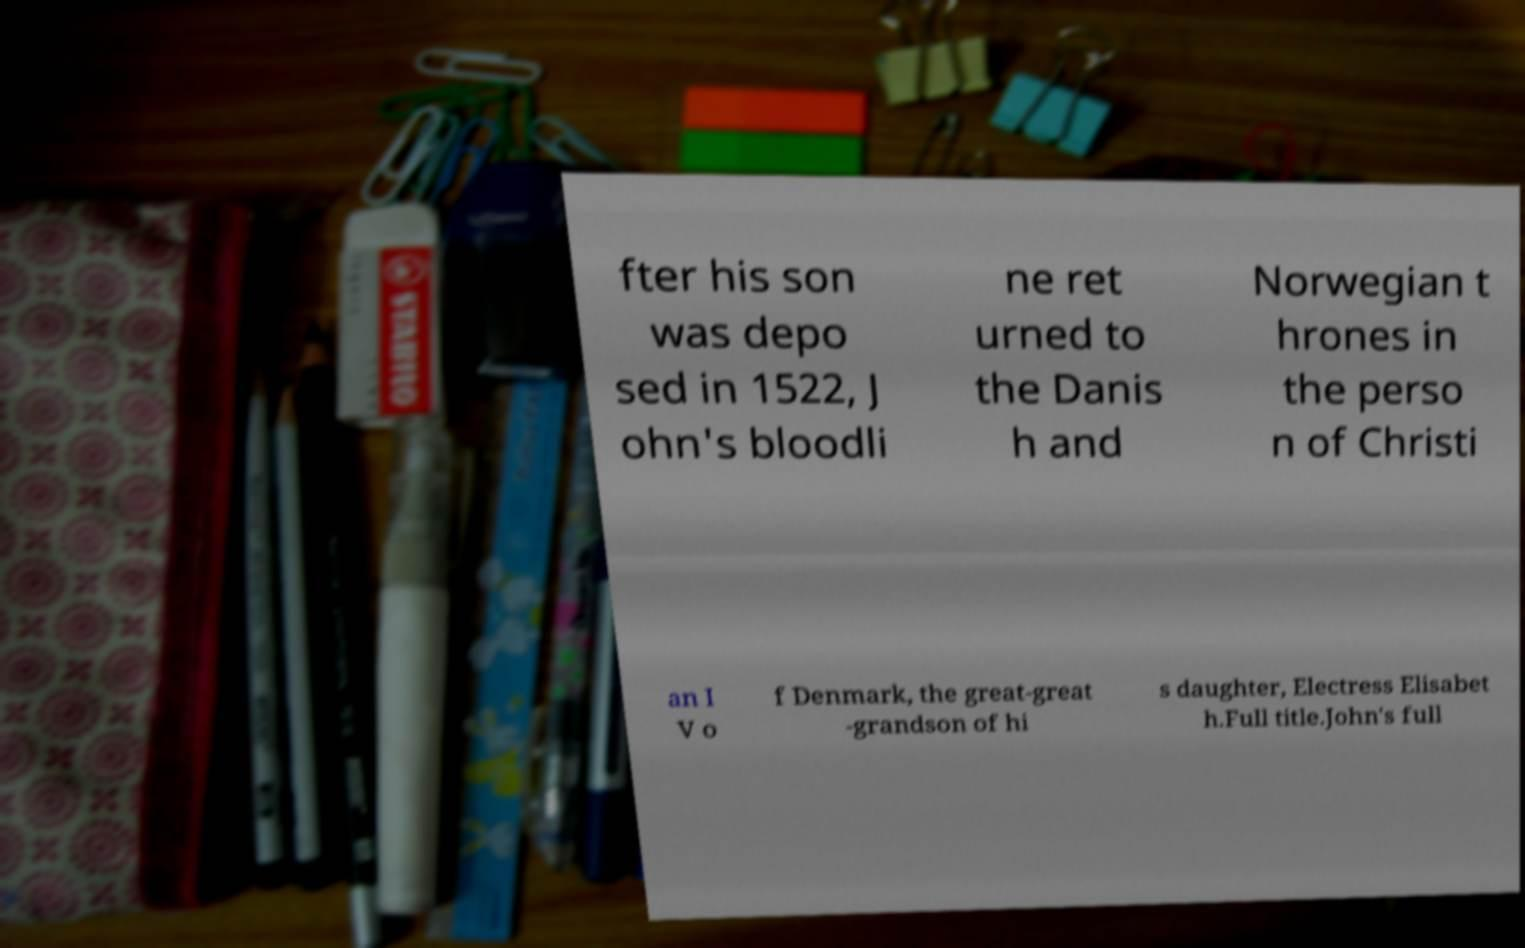I need the written content from this picture converted into text. Can you do that? fter his son was depo sed in 1522, J ohn's bloodli ne ret urned to the Danis h and Norwegian t hrones in the perso n of Christi an I V o f Denmark, the great-great -grandson of hi s daughter, Electress Elisabet h.Full title.John's full 